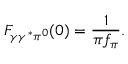Convert formula to latex. <formula><loc_0><loc_0><loc_500><loc_500>F _ { \gamma \gamma ^ { * } \pi ^ { 0 } } ( 0 ) = \frac { 1 } \pi f _ { \pi } } .</formula> 